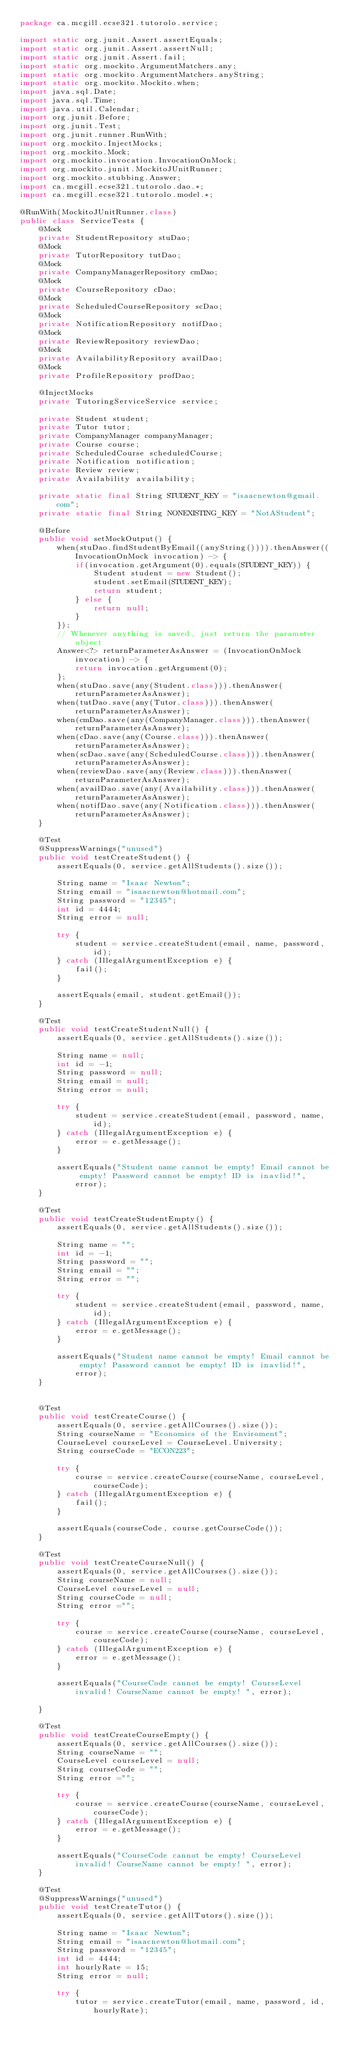<code> <loc_0><loc_0><loc_500><loc_500><_Java_>package ca.mcgill.ecse321.tutorolo.service;

import static org.junit.Assert.assertEquals;
import static org.junit.Assert.assertNull;
import static org.junit.Assert.fail;
import static org.mockito.ArgumentMatchers.any;
import static org.mockito.ArgumentMatchers.anyString;
import static org.mockito.Mockito.when;
import java.sql.Date;
import java.sql.Time;
import java.util.Calendar;
import org.junit.Before;
import org.junit.Test;
import org.junit.runner.RunWith;
import org.mockito.InjectMocks;
import org.mockito.Mock;
import org.mockito.invocation.InvocationOnMock;
import org.mockito.junit.MockitoJUnitRunner;
import org.mockito.stubbing.Answer;
import ca.mcgill.ecse321.tutorolo.dao.*;
import ca.mcgill.ecse321.tutorolo.model.*;

@RunWith(MockitoJUnitRunner.class)
public class ServiceTests {
	@Mock
	private StudentRepository stuDao;
	@Mock
	private TutorRepository tutDao;
	@Mock
	private CompanyManagerRepository cmDao;
	@Mock
	private CourseRepository cDao;
	@Mock
	private ScheduledCourseRepository scDao;
	@Mock
	private NotificationRepository notifDao;
	@Mock
	private ReviewRepository reviewDao;
	@Mock
	private AvailabilityRepository availDao;
	@Mock
	private ProfileRepository profDao;
	
	@InjectMocks
	private TutoringServiceService service;
	
	private Student student;
	private Tutor tutor;
	private CompanyManager companyManager;
	private Course course;
	private ScheduledCourse scheduledCourse;
	private Notification notification;
	private Review review;
	private Availability availability;
	
	private static final String STUDENT_KEY = "isaacnewton@gmail.com";
	private static final String NONEXISTING_KEY = "NotAStudent";
	
	@Before
	public void setMockOutput() {
		when(stuDao.findStudentByEmail((anyString()))).thenAnswer((InvocationOnMock invocation) -> {
			if(invocation.getArgument(0).equals(STUDENT_KEY)) {
				Student student = new Student();
				student.setEmail(STUDENT_KEY);
				return student;
			} else {
				return null;
			}
		});
		// Whenever anything is saved, just return the parameter object
		Answer<?> returnParameterAsAnswer = (InvocationOnMock invocation) -> {
			return invocation.getArgument(0);
		};
		when(stuDao.save(any(Student.class))).thenAnswer(returnParameterAsAnswer);
		when(tutDao.save(any(Tutor.class))).thenAnswer(returnParameterAsAnswer);
		when(cmDao.save(any(CompanyManager.class))).thenAnswer(returnParameterAsAnswer);
		when(cDao.save(any(Course.class))).thenAnswer(returnParameterAsAnswer);
		when(scDao.save(any(ScheduledCourse.class))).thenAnswer(returnParameterAsAnswer);
		when(reviewDao.save(any(Review.class))).thenAnswer(returnParameterAsAnswer);
		when(availDao.save(any(Availability.class))).thenAnswer(returnParameterAsAnswer);
		when(notifDao.save(any(Notification.class))).thenAnswer(returnParameterAsAnswer);
	}
	
	@Test
	@SuppressWarnings("unused")
	public void testCreateStudent() {
		assertEquals(0, service.getAllStudents().size());

		String name = "Isaac Newton";
		String email = "isaacnewton@hotmail.com";
		String password = "12345";
		int id = 4444;
		String error = null;

		try {
			student = service.createStudent(email, name, password, id);
		} catch (IllegalArgumentException e) {
			fail();
		}

		assertEquals(email, student.getEmail());
	}
	
	@Test
	public void testCreateStudentNull() {
		assertEquals(0, service.getAllStudents().size());
		
		String name = null;
		int id = -1;
		String password = null;
		String email = null;
		String error = null;

		try {
			student = service.createStudent(email, password, name, id);
		} catch (IllegalArgumentException e) {
			error = e.getMessage();
		}

		assertEquals("Student name cannot be empty! Email cannot be empty! Password cannot be empty! ID is inavlid!", error);
	}
	
	@Test
	public void testCreateStudentEmpty() {
		assertEquals(0, service.getAllStudents().size());
		
		String name = "";
		int id = -1;
		String password = "";
		String email = "";
		String error = "";

		try {
			student = service.createStudent(email, password, name, id);
		} catch (IllegalArgumentException e) {
			error = e.getMessage();
		}

		assertEquals("Student name cannot be empty! Email cannot be empty! Password cannot be empty! ID is inavlid!", error);
	}
		
	
	@Test
	public void testCreateCourse() {
		assertEquals(0, service.getAllCourses().size());
		String courseName = "Economics of the Enviroment";
		CourseLevel courseLevel = CourseLevel.University;
		String courseCode = "ECON223";
		
		try {
			course = service.createCourse(courseName, courseLevel, courseCode);
		} catch (IllegalArgumentException e) {
			fail();
		}
		
		assertEquals(courseCode, course.getCourseCode());
	}
	
	@Test
	public void testCreateCourseNull() {
		assertEquals(0, service.getAllCourses().size());
		String courseName = null;
		CourseLevel courseLevel = null;
		String courseCode = null;
		String error ="";
		
		try {
			course = service.createCourse(courseName, courseLevel, courseCode);
		} catch (IllegalArgumentException e) {
			error = e.getMessage();
		}
		
		assertEquals("CourseCode cannot be empty! CourseLevel invalid! CourseName cannot be empty! ", error);
		
	}
	
	@Test
	public void testCreateCourseEmpty() {
		assertEquals(0, service.getAllCourses().size());
		String courseName = "";
		CourseLevel courseLevel = null;
		String courseCode = "";
		String error ="";
		
		try {
			course = service.createCourse(courseName, courseLevel, courseCode);
		} catch (IllegalArgumentException e) {
			error = e.getMessage();
		}
		
		assertEquals("CourseCode cannot be empty! CourseLevel invalid! CourseName cannot be empty! ", error);
	}
	
	@Test
	@SuppressWarnings("unused")
	public void testCreateTutor() {
		assertEquals(0, service.getAllTutors().size());

		String name = "Isaac Newton";
		String email = "isaacnewton@hotmail.com";
		String password = "12345";
		int id = 4444;
		int hourlyRate = 15;
		String error = null;

		try {
			tutor = service.createTutor(email, name, password, id, hourlyRate);</code> 